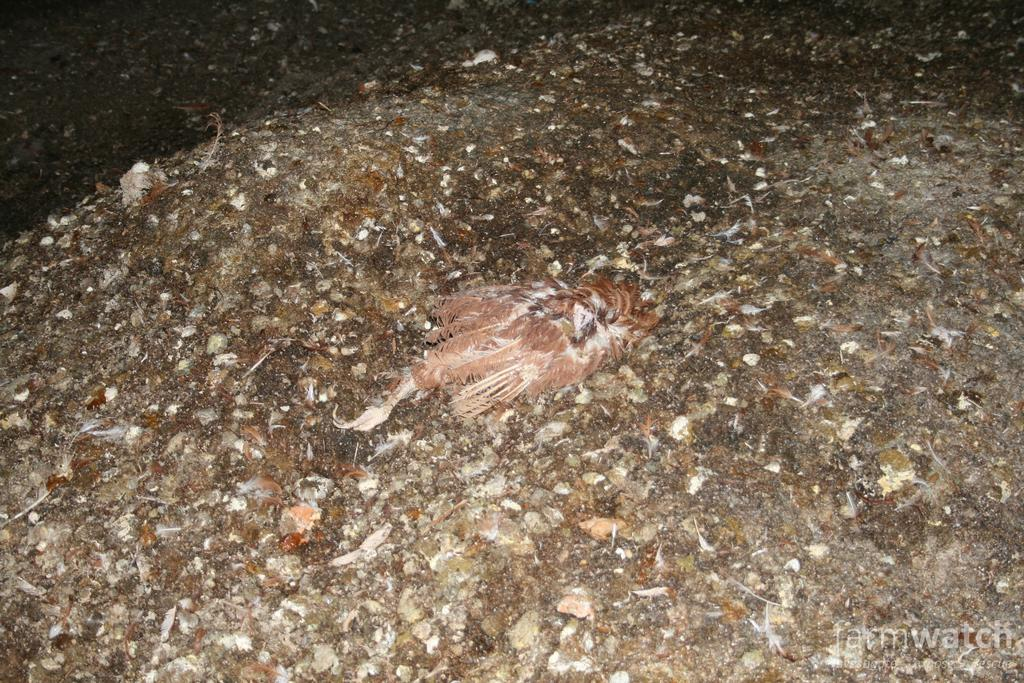What type of surface is visible in the image? There is a rock or stone surface in the image. What other objects or elements can be seen on the surface? There is a group of bird feathers in the image. What flavor of frog can be seen in the image? There is no frog present in the image, and therefore no flavor can be determined. 